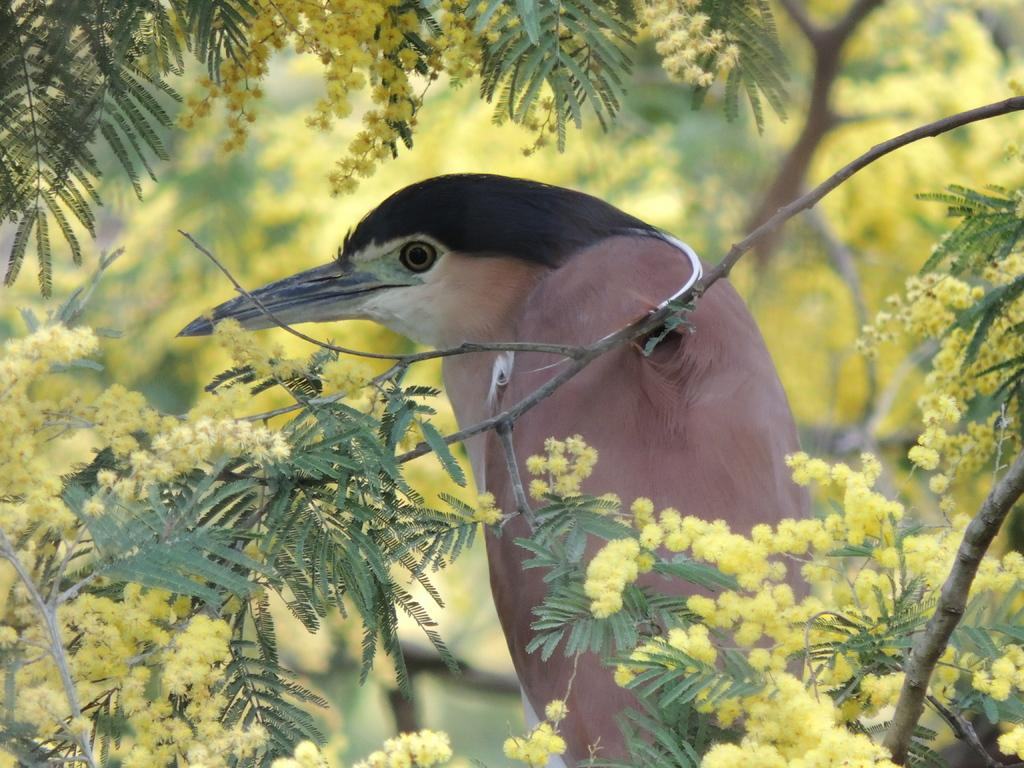What type of animal can be seen in the image? There is a bird in the image. What is in front of the bird? There are branches with flowers and leaves in front of the bird. What can be seen in the background of the image? There are branches with flowers and leaves in the background of the image. What is the bird's opinion on the current state of the economy? Birds do not have opinions, as they are animals and not capable of forming opinions on complex topics like the economy. 